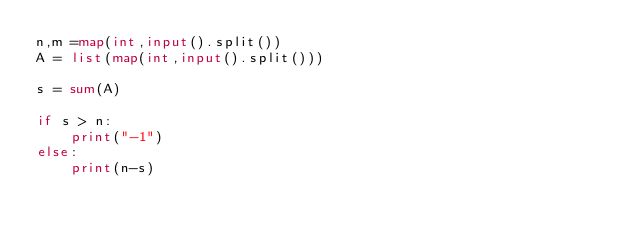<code> <loc_0><loc_0><loc_500><loc_500><_Python_>n,m =map(int,input().split())
A = list(map(int,input().split()))

s = sum(A)

if s > n:
    print("-1")
else:
    print(n-s)</code> 